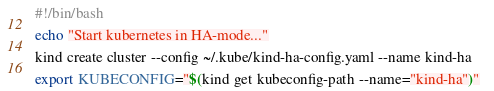Convert code to text. <code><loc_0><loc_0><loc_500><loc_500><_Bash_>#!/bin/bash

echo "Start kubernetes in HA-mode..."

kind create cluster --config ~/.kube/kind-ha-config.yaml --name kind-ha

export KUBECONFIG="$(kind get kubeconfig-path --name="kind-ha")"  
</code> 